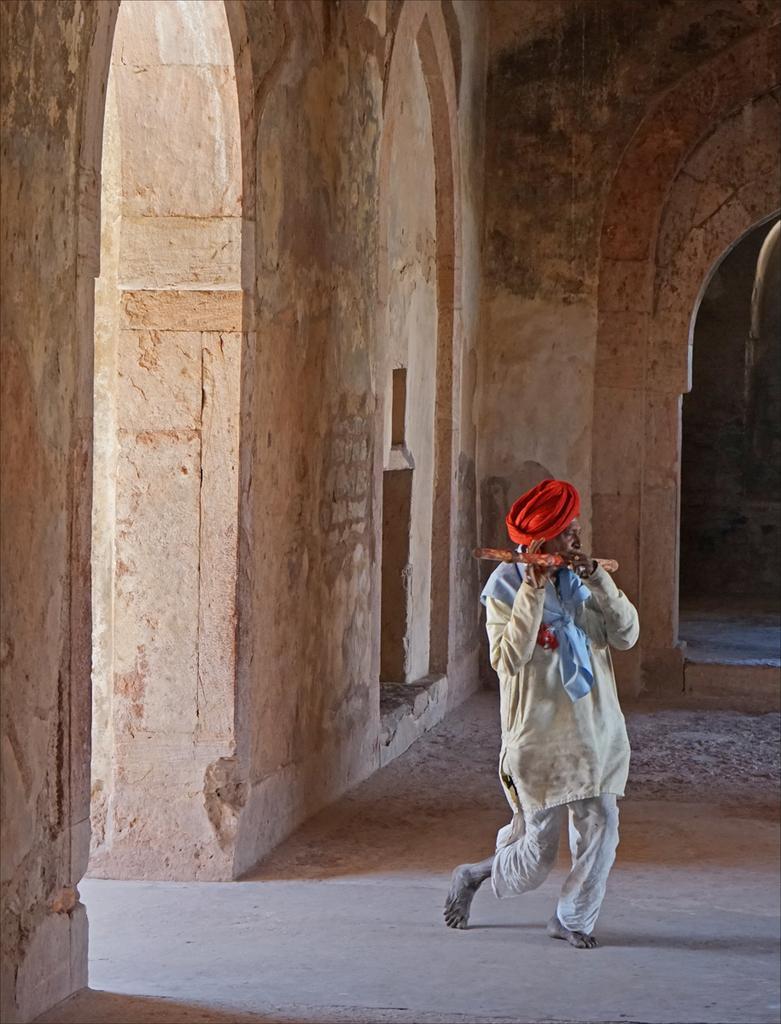How would you summarize this image in a sentence or two? In this picture, we see a man is wearing a white kurta and a red dastar. He is holding a flute in his hand and he is playing it. In the background, we see a wall. On the right side, we see an arch. 